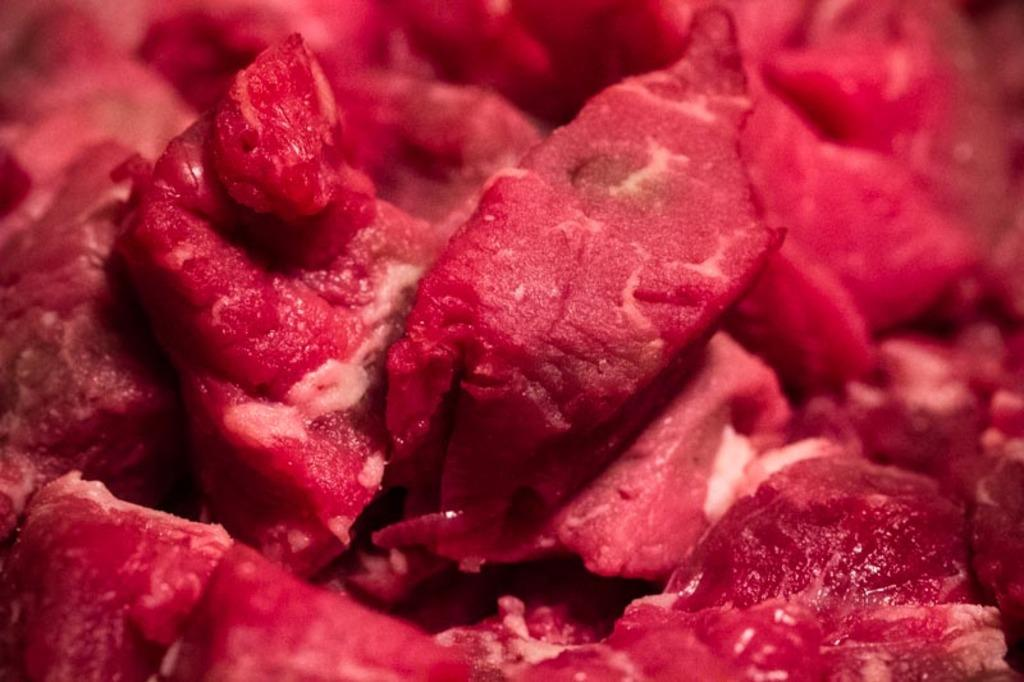What type of food is visible in the image? There is raw meat in the image. Can you see any bones sticking out of the raw meat in the image? There are no bones visible in the image, as it only shows raw meat. Who is the friend of the raw meat in the image? There is no friend present in the image, as it only shows raw meat. 